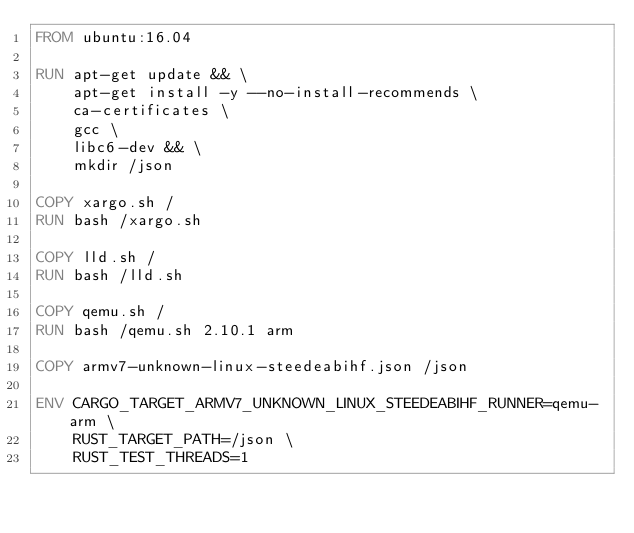<code> <loc_0><loc_0><loc_500><loc_500><_Dockerfile_>FROM ubuntu:16.04

RUN apt-get update && \
    apt-get install -y --no-install-recommends \
    ca-certificates \
    gcc \
    libc6-dev && \
    mkdir /json

COPY xargo.sh /
RUN bash /xargo.sh

COPY lld.sh /
RUN bash /lld.sh

COPY qemu.sh /
RUN bash /qemu.sh 2.10.1 arm

COPY armv7-unknown-linux-steedeabihf.json /json

ENV CARGO_TARGET_ARMV7_UNKNOWN_LINUX_STEEDEABIHF_RUNNER=qemu-arm \
    RUST_TARGET_PATH=/json \
    RUST_TEST_THREADS=1
</code> 